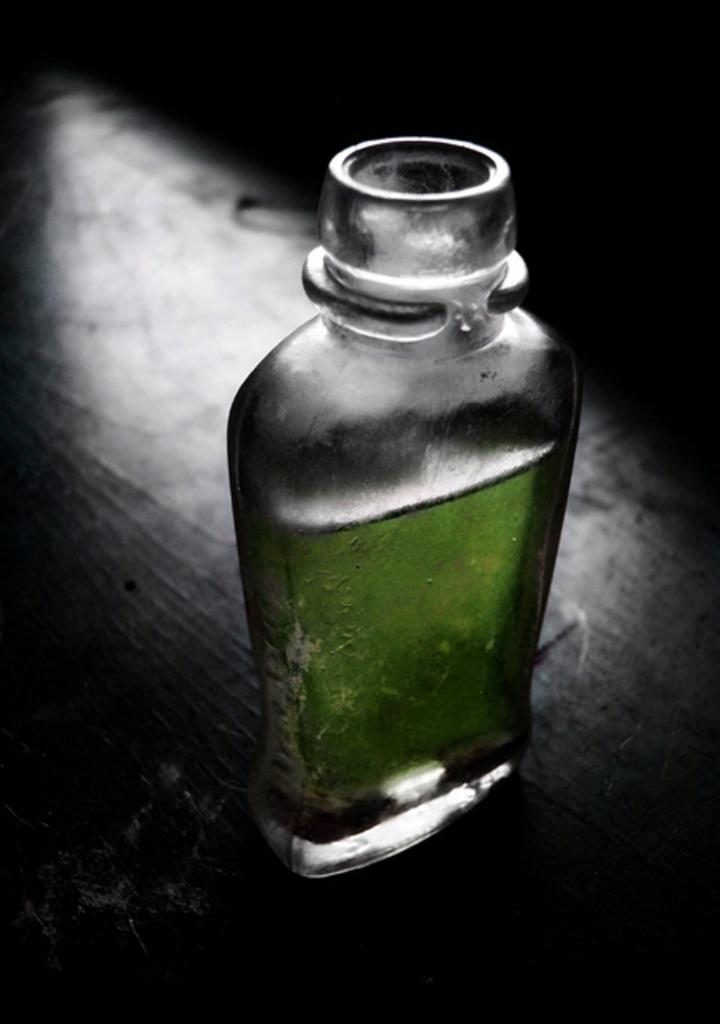What object is present in the image that is filled with liquid? There is a bottle in the image that is filled with liquid. What type of bedroom furniture can be seen in the image? There is no bedroom furniture present in the image; it only features a bottle filled with liquid. Where is the faucet located in the image? There is no faucet present in the image; it only features a bottle filled with liquid. 